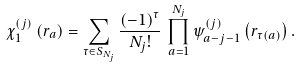<formula> <loc_0><loc_0><loc_500><loc_500>\chi _ { 1 } ^ { ( j ) } \left ( { r } _ { a } \right ) = \sum _ { \tau \in S _ { N _ { j } } } \frac { \left ( - 1 \right ) ^ { \tau } } { N _ { j } ! } \, \prod _ { a = 1 } ^ { N _ { j } } \psi ^ { ( j ) } _ { a - j - 1 } \left ( { r } _ { \tau \left ( a \right ) } \right ) .</formula> 